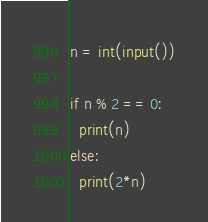<code> <loc_0><loc_0><loc_500><loc_500><_Python_>n = int(input())

if n % 2 == 0:
  print(n)
else:
  print(2*n)</code> 